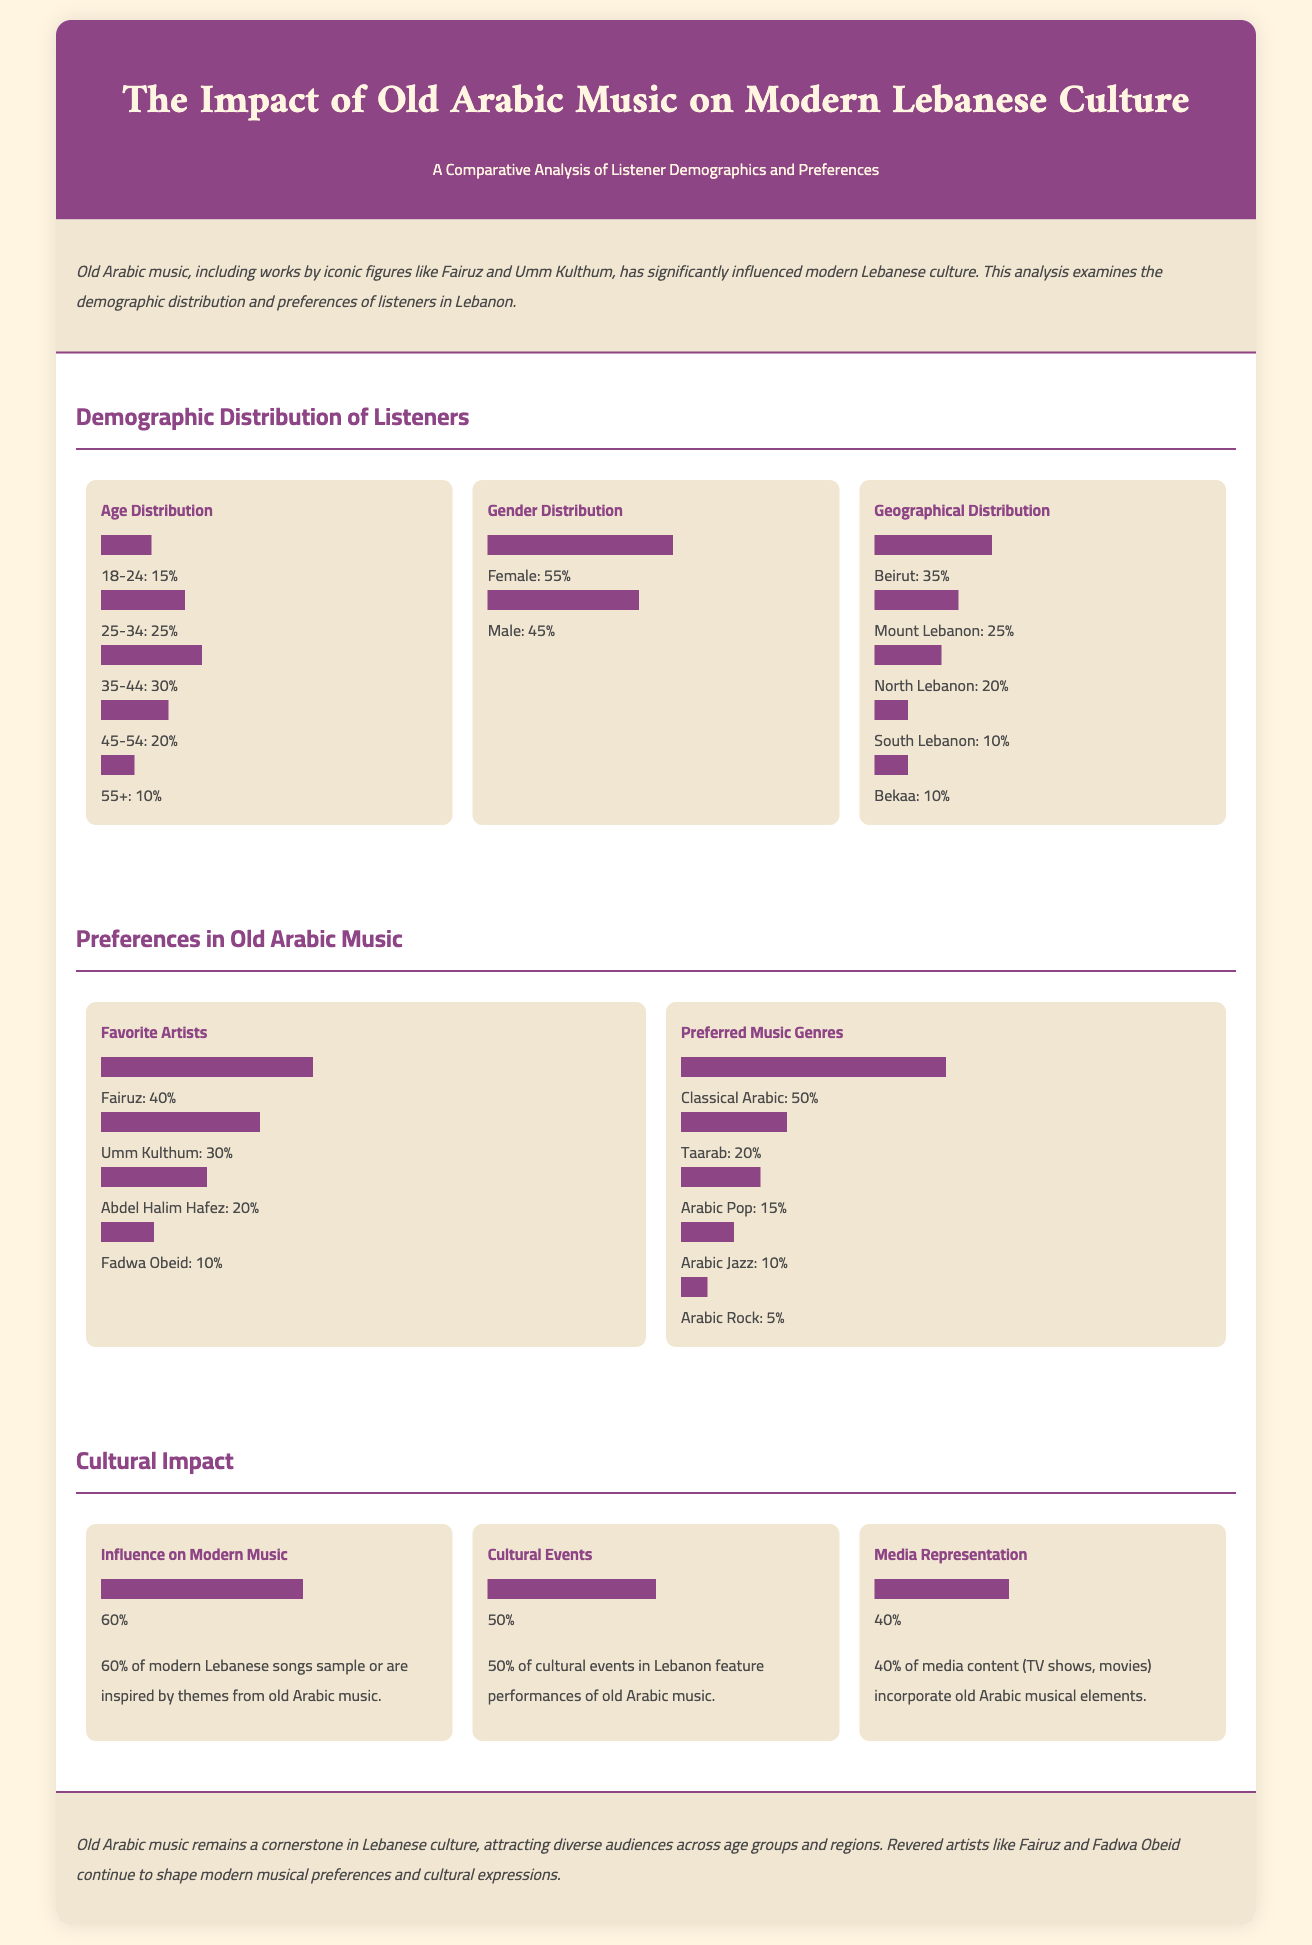what percentage of listeners are aged 35-44? In the demographic distribution section, it shows that 30% of listeners fall in the age category of 35-44.
Answer: 30% which gender has a higher listener percentage? The gender distribution chart indicates that 55% of listeners are female, while 45% are male.
Answer: Female what is the favorite artist among listeners? According to the preferences section, the artist that has the highest percentage of preference is Fairuz at 40%.
Answer: Fairuz how many cultural events feature old Arabic music in Lebanon? The cultural impact section highlights that 50% of cultural events in Lebanon feature performances of old Arabic music.
Answer: 50% what percentage of modern Lebanese songs are inspired by old Arabic music? It is stated that 60% of modern Lebanese songs sample or are inspired by themes from old Arabic music.
Answer: 60% which age group has the lowest listener percentage? The age distribution shows that the lowest percentage of listeners is in the 55+ age group, with 10%.
Answer: 55+ what percentage of listeners preferred classical Arabic music? In the preferences section, it states that 50% of listeners prefer classical Arabic music.
Answer: 50% how many geographical regions are represented in the listener distribution? The geographical distribution section includes five regions: Beirut, Mount Lebanon, North Lebanon, South Lebanon, and Bekaa.
Answer: Five 